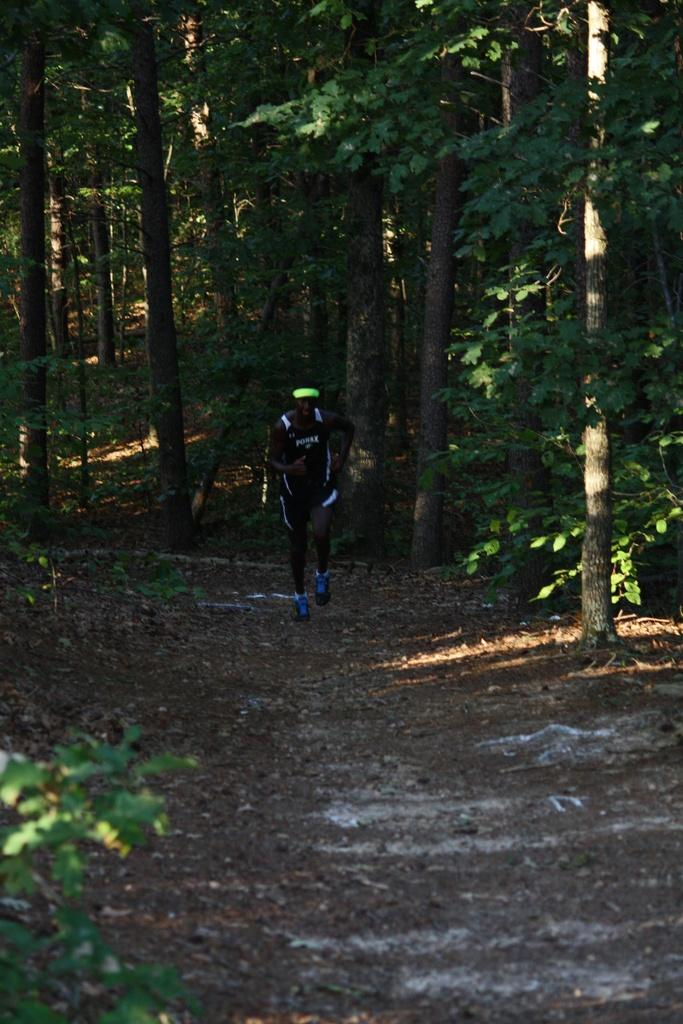What is the main subject of the image? There is an athlete in the image. What is the athlete doing in the image? The athlete is running in the image. What can be seen in the background of the image? There are trees visible behind the athlete in the image. How many folds can be seen in the athlete's clothing in the image? There are no folds visible in the athlete's clothing in the image. Is there a gun visible in the image? No, there is no gun present in the image. 